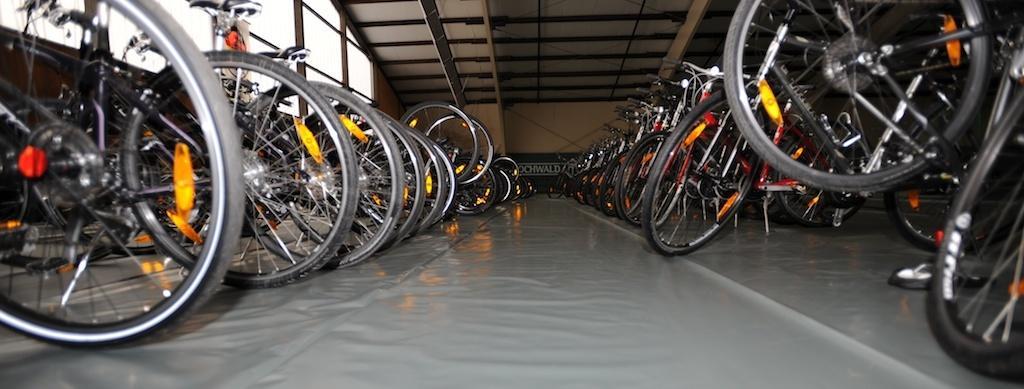Describe this image in one or two sentences. In this image we can see the bicycles. We can also see the wall, text board, windows and also the roof for shelter. At the bottom we can see the floor. 